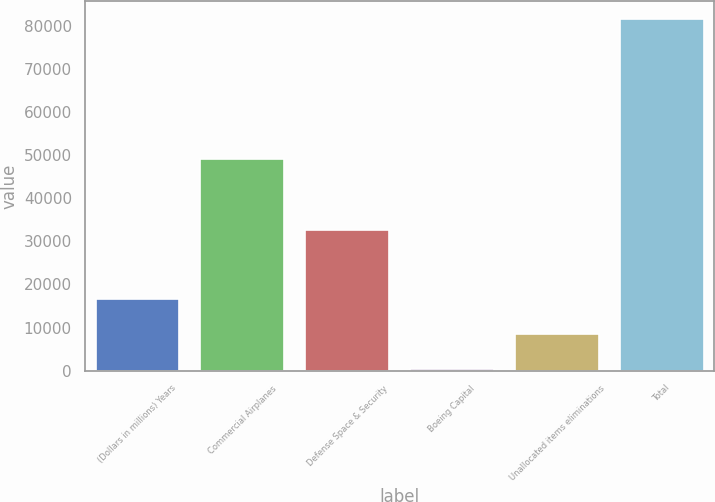<chart> <loc_0><loc_0><loc_500><loc_500><bar_chart><fcel>(Dollars in millions) Years<fcel>Commercial Airplanes<fcel>Defense Space & Security<fcel>Boeing Capital<fcel>Unallocated items eliminations<fcel>Total<nl><fcel>16714<fcel>49127<fcel>32607<fcel>468<fcel>8591<fcel>81698<nl></chart> 